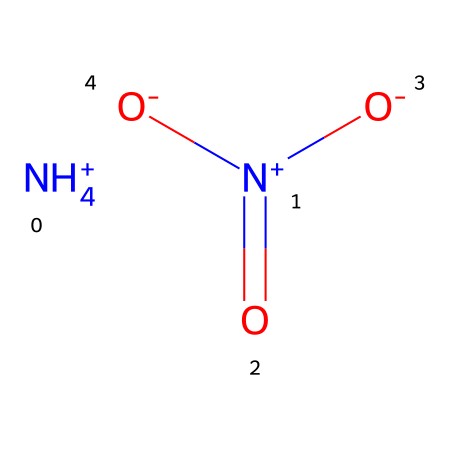How many nitrogen atoms are present in ammonium nitrate? The SMILES representation shows two nitrogen atoms: one in the ammonium ion (NH4+) and one in the nitrate ion (N+).
Answer: two What is the charge of the ammonium ion in this compound? In the structure, the ammonium ion is represented as [NH4+], indicating it has a positive charge due to the four hydrogen atoms bonding to nitrogen.
Answer: positive What type of bond connects the nitrogen to the oxygen in the nitrate ion? The nitrate ion (N+)(=O)([O-])[O-] shows that nitrogen is double bonded to one oxygen atom, indicating a double bond.
Answer: double bond How many oxygen atoms are in ammonium nitrate? The nitrate ion has three oxygen atoms connected to the nitrogen atom, and there are no additional oxygen atoms in the ammonium ion.
Answer: three What makes ammonium nitrate a hypervalent compound? Ammonium nitrate contains nitrogen with a positive formal charge in its nitrate form, allowing nitrogen to exceed the octet rule by bonding with more than four electrons, characterizing it as hypervalent.
Answer: hypervalent 